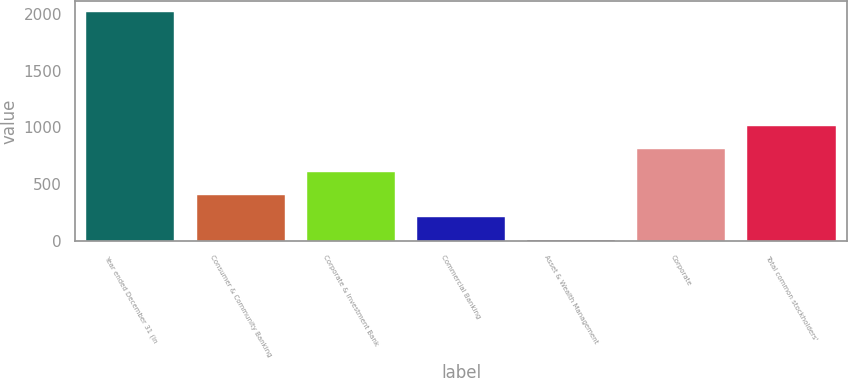Convert chart. <chart><loc_0><loc_0><loc_500><loc_500><bar_chart><fcel>Year ended December 31 (in<fcel>Consumer & Community Banking<fcel>Corporate & Investment Bank<fcel>Commercial Banking<fcel>Asset & Wealth Management<fcel>Corporate<fcel>Total common stockholders'<nl><fcel>2014<fcel>410<fcel>610.5<fcel>209.5<fcel>9<fcel>811<fcel>1011.5<nl></chart> 